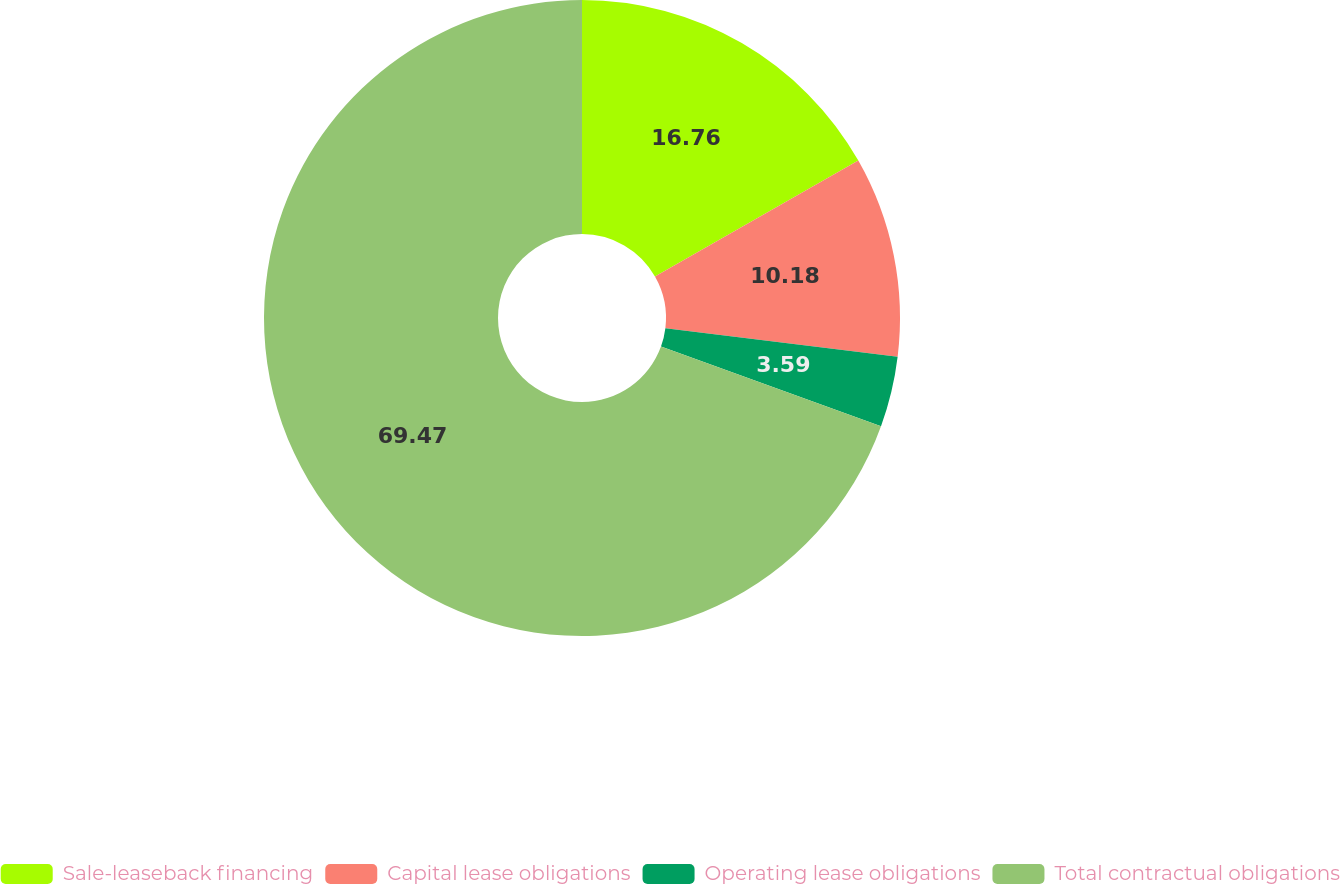<chart> <loc_0><loc_0><loc_500><loc_500><pie_chart><fcel>Sale-leaseback financing<fcel>Capital lease obligations<fcel>Operating lease obligations<fcel>Total contractual obligations<nl><fcel>16.76%<fcel>10.18%<fcel>3.59%<fcel>69.47%<nl></chart> 